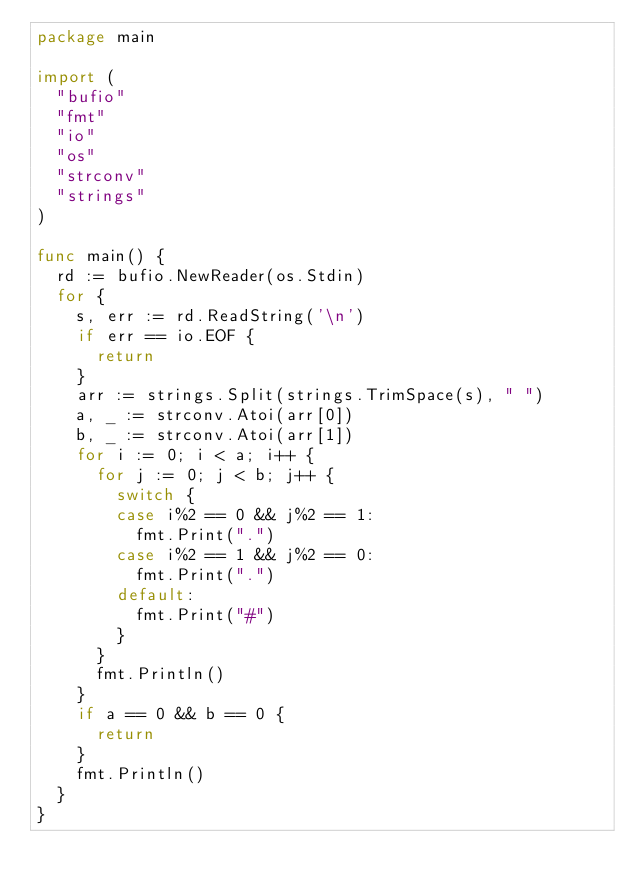Convert code to text. <code><loc_0><loc_0><loc_500><loc_500><_Go_>package main

import (
	"bufio"
	"fmt"
	"io"
	"os"
	"strconv"
	"strings"
)

func main() {
	rd := bufio.NewReader(os.Stdin)
	for {
		s, err := rd.ReadString('\n')
		if err == io.EOF {
			return
		}
		arr := strings.Split(strings.TrimSpace(s), " ")
		a, _ := strconv.Atoi(arr[0])
		b, _ := strconv.Atoi(arr[1])
		for i := 0; i < a; i++ {
			for j := 0; j < b; j++ {
				switch {
				case i%2 == 0 && j%2 == 1:
					fmt.Print(".")
				case i%2 == 1 && j%2 == 0:
					fmt.Print(".")
				default:
					fmt.Print("#")
				}
			}
			fmt.Println()
		}
		if a == 0 && b == 0 {
			return
		}
		fmt.Println()
	}
}

</code> 